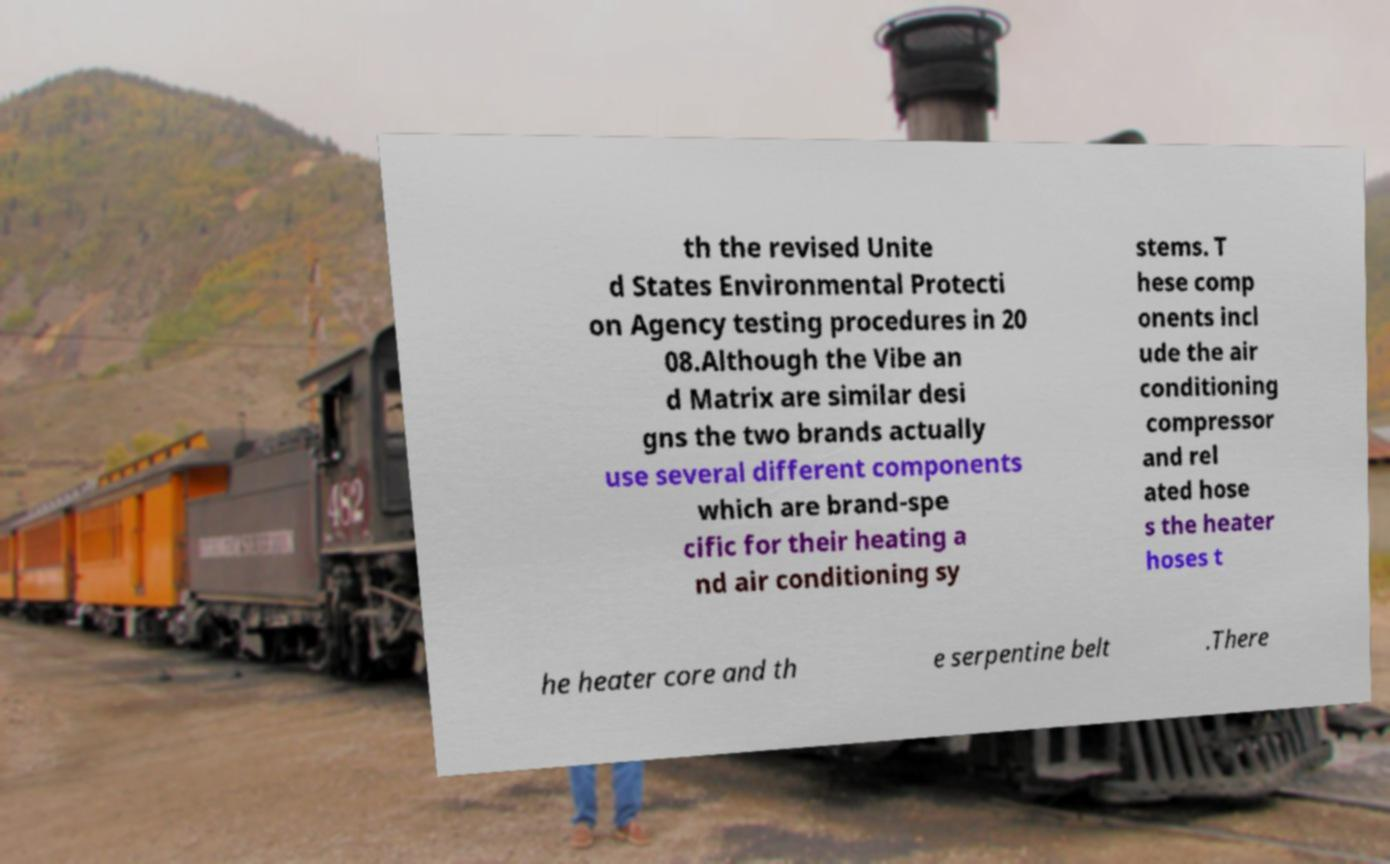What messages or text are displayed in this image? I need them in a readable, typed format. th the revised Unite d States Environmental Protecti on Agency testing procedures in 20 08.Although the Vibe an d Matrix are similar desi gns the two brands actually use several different components which are brand-spe cific for their heating a nd air conditioning sy stems. T hese comp onents incl ude the air conditioning compressor and rel ated hose s the heater hoses t he heater core and th e serpentine belt .There 